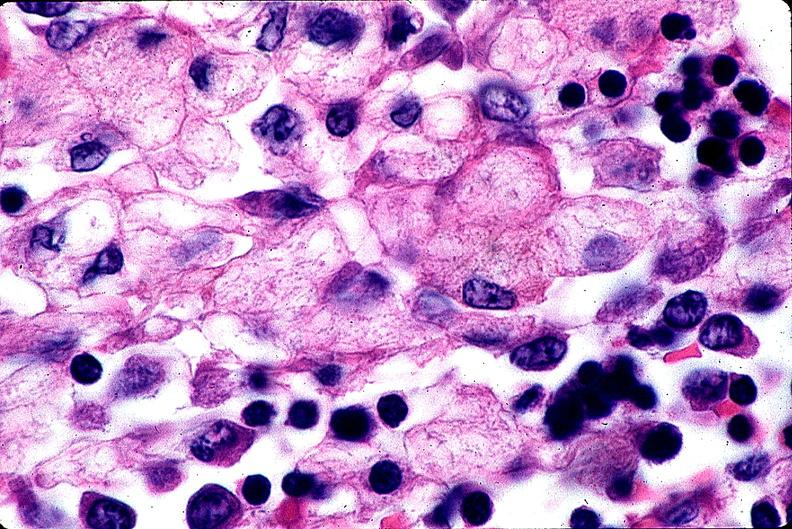what does this image show?
Answer the question using a single word or phrase. Gaucher disease 